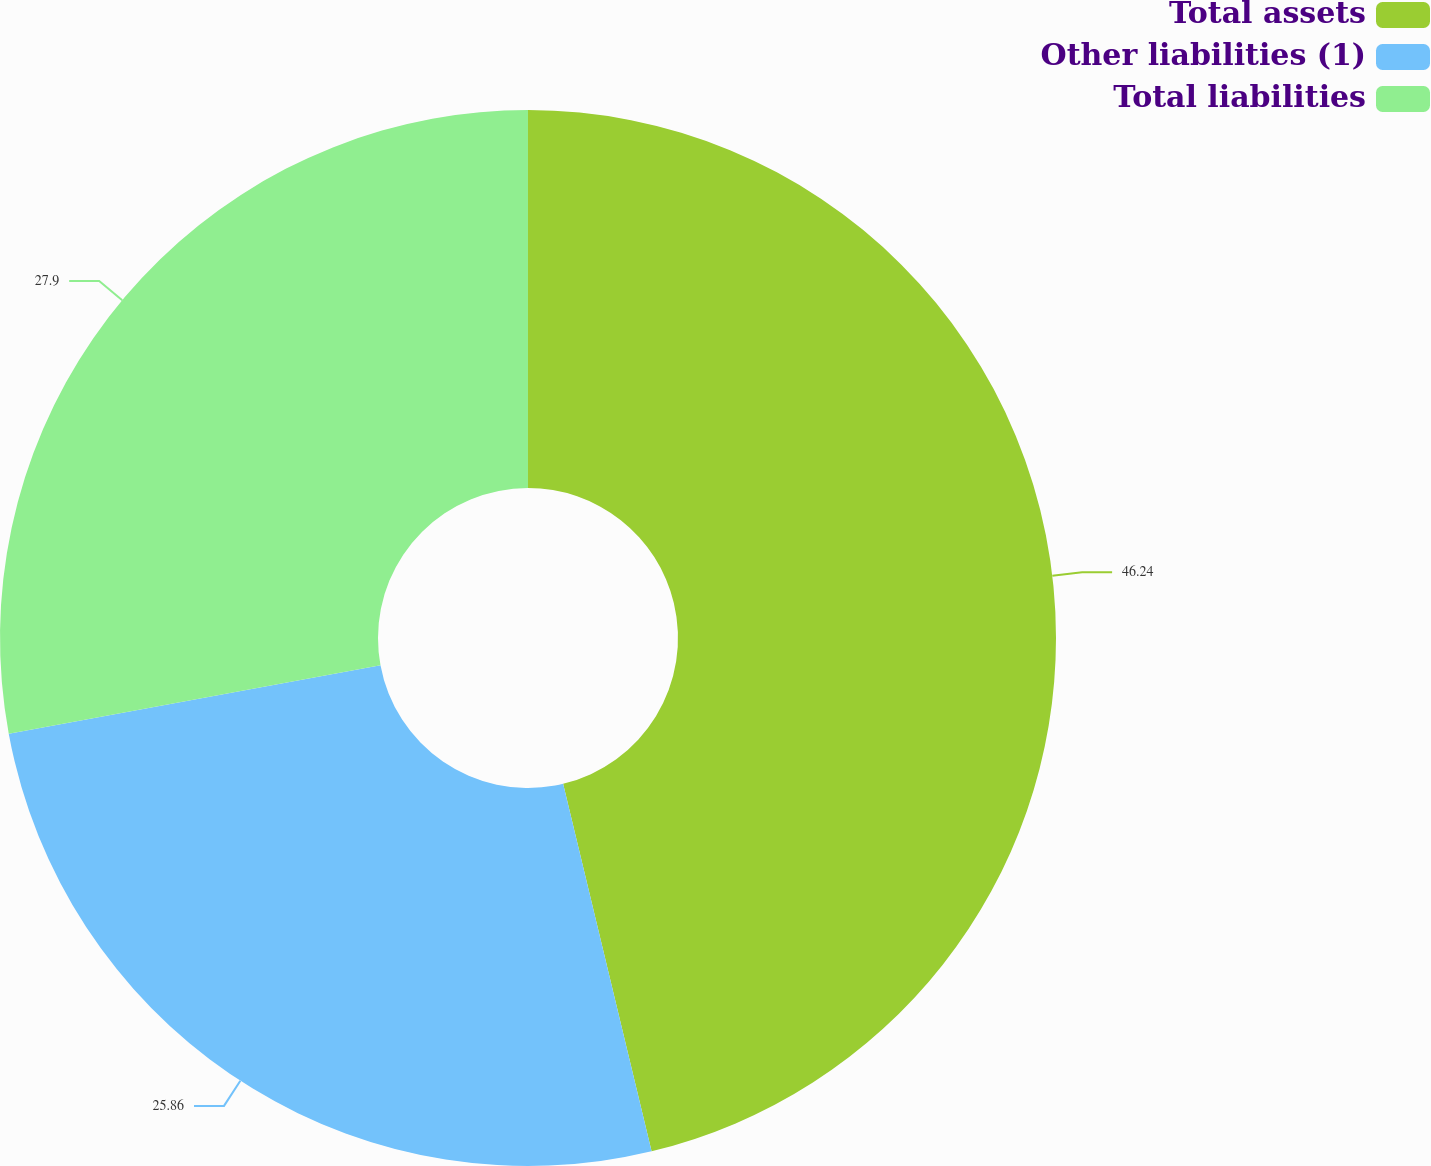Convert chart. <chart><loc_0><loc_0><loc_500><loc_500><pie_chart><fcel>Total assets<fcel>Other liabilities (1)<fcel>Total liabilities<nl><fcel>46.24%<fcel>25.86%<fcel>27.9%<nl></chart> 